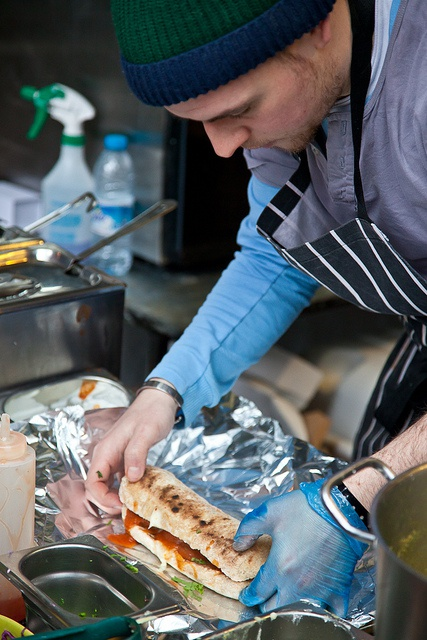Describe the objects in this image and their specific colors. I can see people in black, gray, and lightblue tones, bowl in black, gray, darkgray, and darkgreen tones, sandwich in black, tan, and beige tones, bottle in black, lightblue, darkgray, and lightgray tones, and bottle in black, gray, and lightblue tones in this image. 